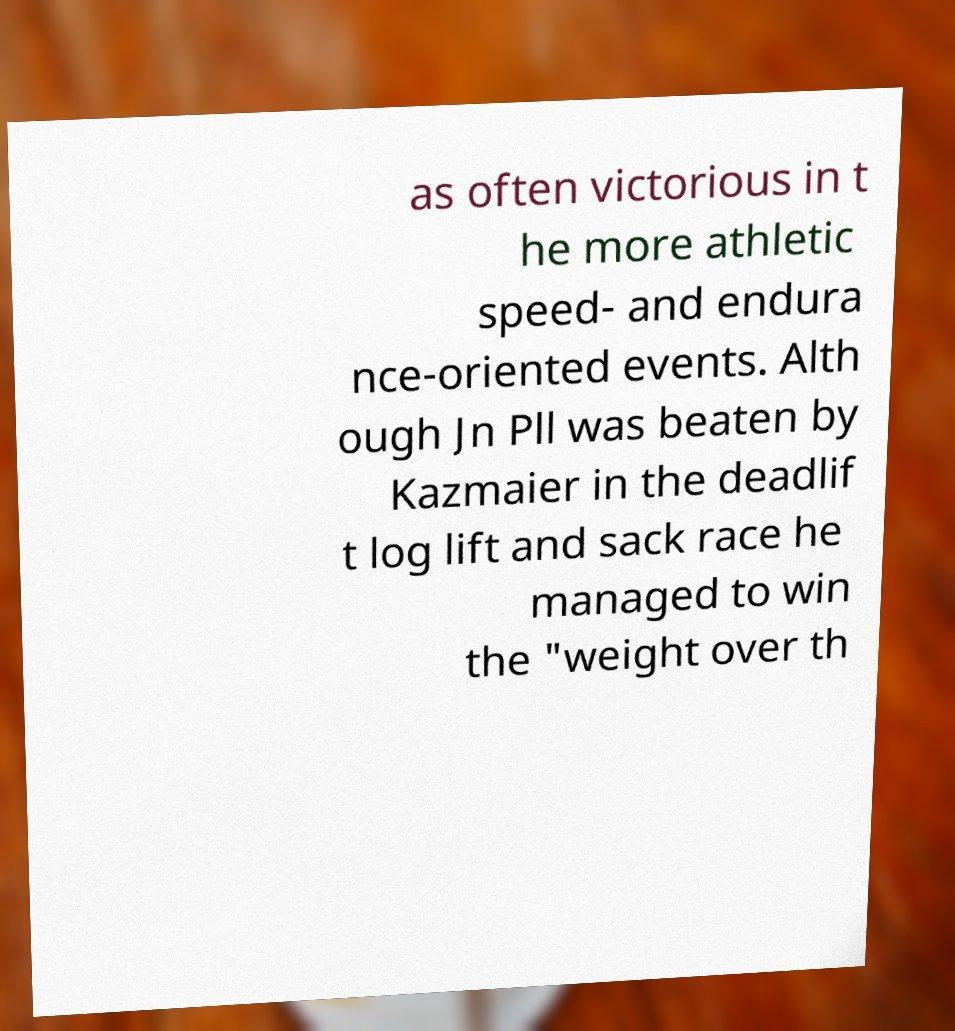Can you accurately transcribe the text from the provided image for me? as often victorious in t he more athletic speed- and endura nce-oriented events. Alth ough Jn Pll was beaten by Kazmaier in the deadlif t log lift and sack race he managed to win the "weight over th 